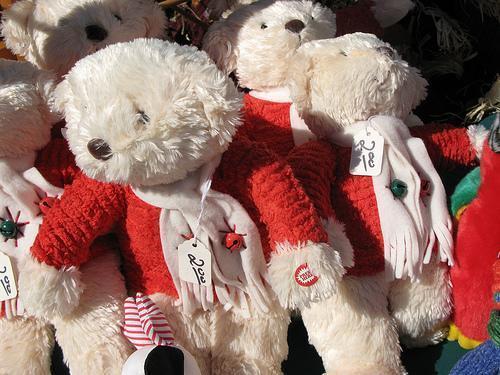How many teddy bears?
Give a very brief answer. 5. How many bears are looking skyward?
Give a very brief answer. 2. 